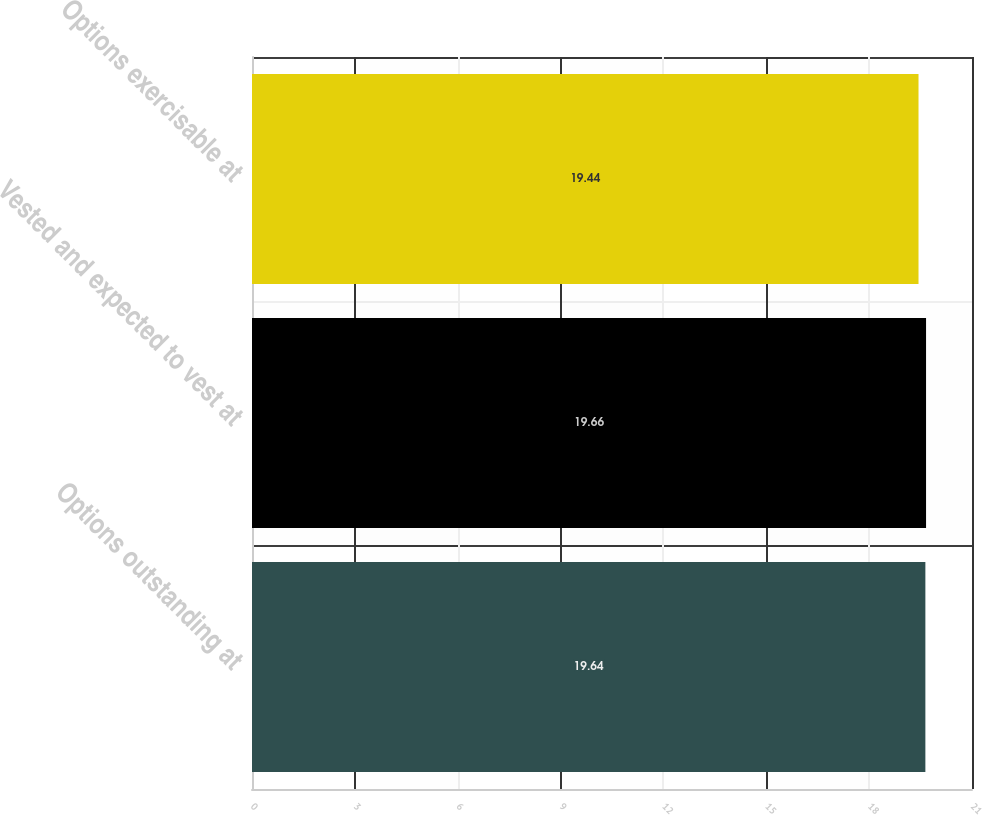Convert chart. <chart><loc_0><loc_0><loc_500><loc_500><bar_chart><fcel>Options outstanding at<fcel>Vested and expected to vest at<fcel>Options exercisable at<nl><fcel>19.64<fcel>19.66<fcel>19.44<nl></chart> 